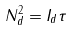Convert formula to latex. <formula><loc_0><loc_0><loc_500><loc_500>N ^ { 2 } _ { d } = I _ { d } \tau</formula> 